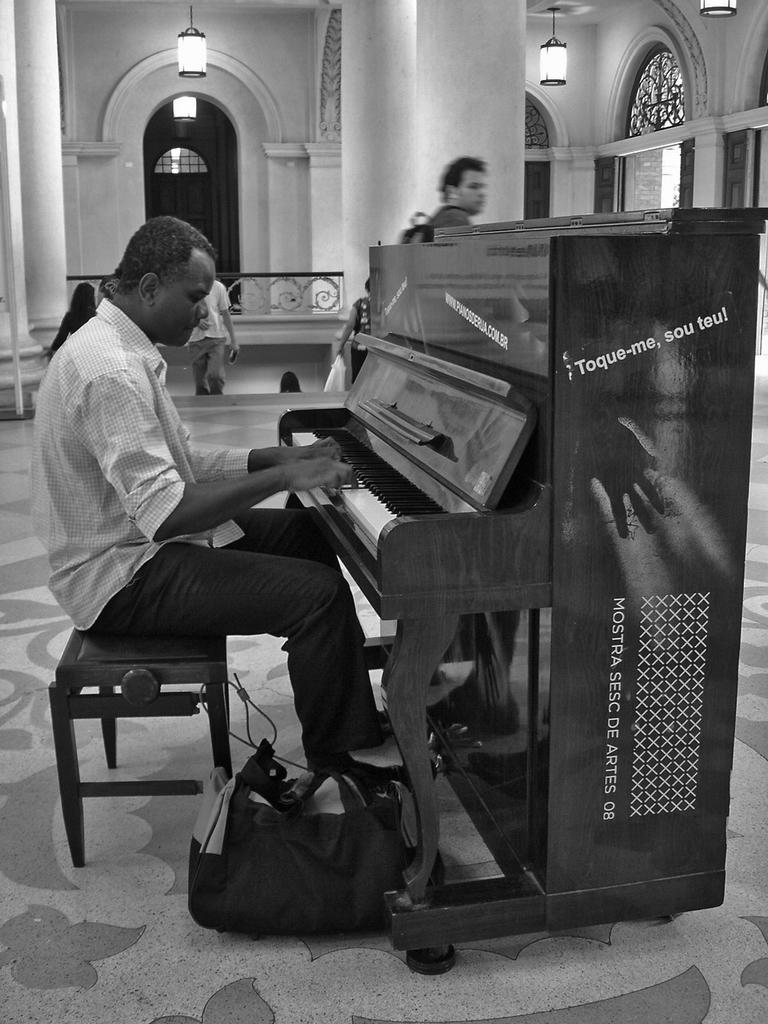What is the main activity of the man in the image? The man in the image is playing a piano. Can you describe another person's action in the image? There is another man walking in the image. What type of fuel is required for the piano to function in the image? The piano does not require fuel to function; it is a musical instrument played by the man. 